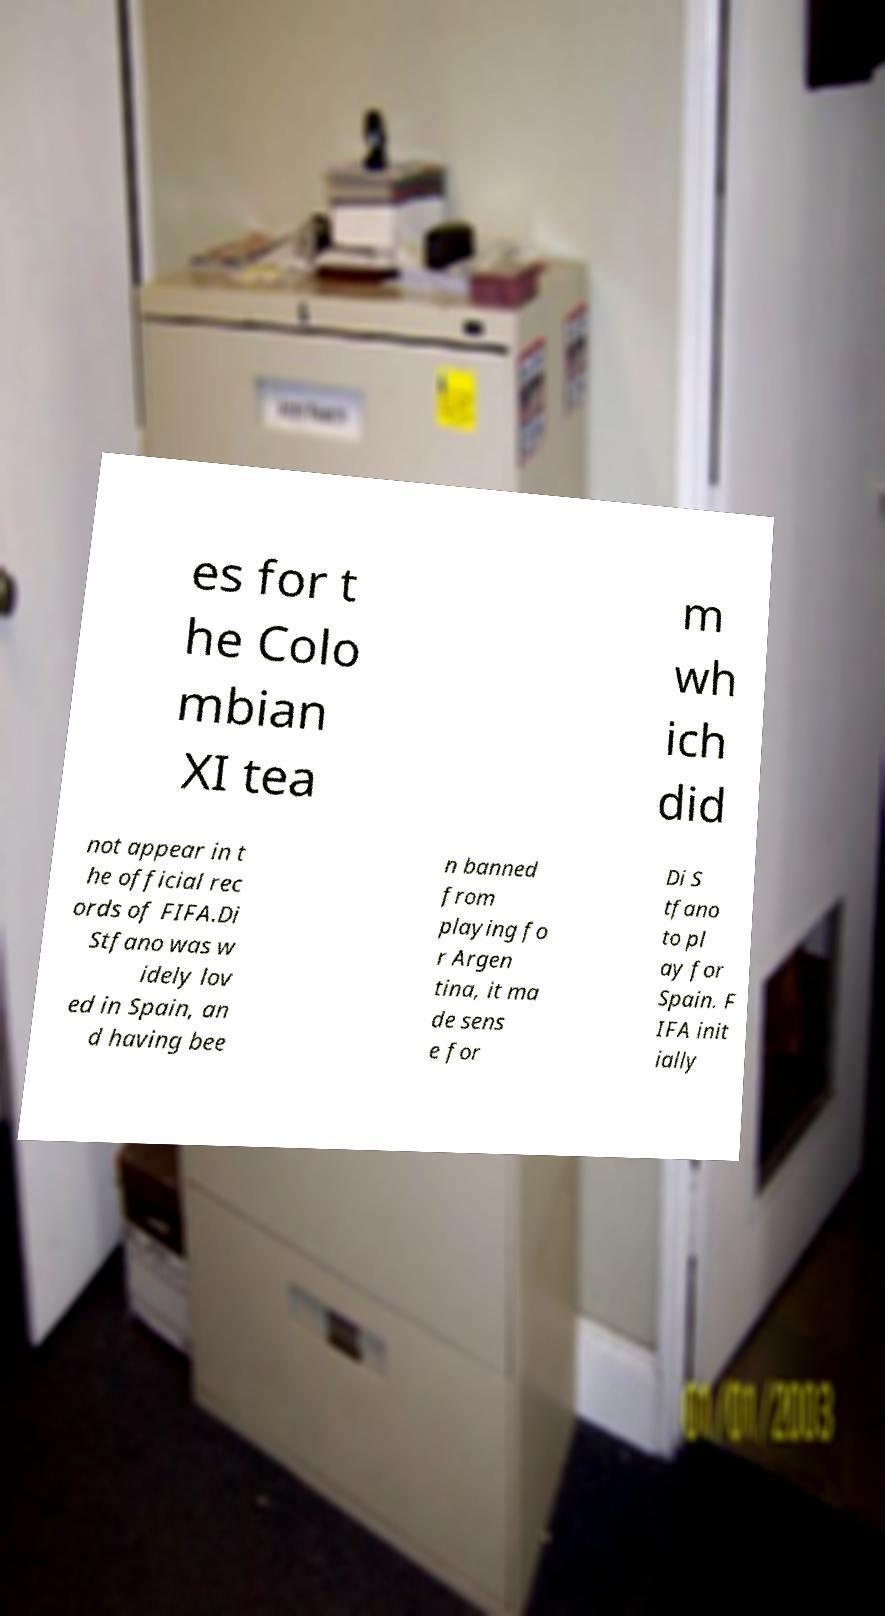Can you read and provide the text displayed in the image?This photo seems to have some interesting text. Can you extract and type it out for me? es for t he Colo mbian XI tea m wh ich did not appear in t he official rec ords of FIFA.Di Stfano was w idely lov ed in Spain, an d having bee n banned from playing fo r Argen tina, it ma de sens e for Di S tfano to pl ay for Spain. F IFA init ially 